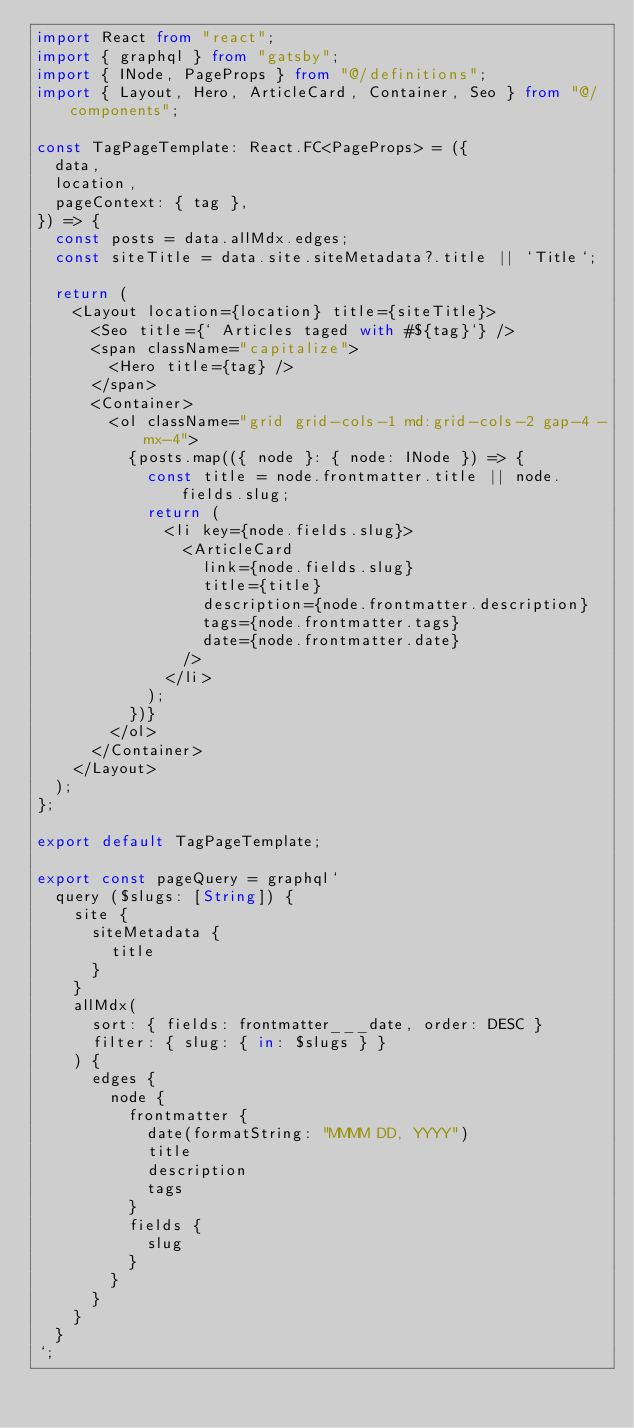Convert code to text. <code><loc_0><loc_0><loc_500><loc_500><_TypeScript_>import React from "react";
import { graphql } from "gatsby";
import { INode, PageProps } from "@/definitions";
import { Layout, Hero, ArticleCard, Container, Seo } from "@/components";

const TagPageTemplate: React.FC<PageProps> = ({
  data,
  location,
  pageContext: { tag },
}) => {
  const posts = data.allMdx.edges;
  const siteTitle = data.site.siteMetadata?.title || `Title`;

  return (
    <Layout location={location} title={siteTitle}>
      <Seo title={` Articles taged with #${tag}`} />
      <span className="capitalize">
        <Hero title={tag} />
      </span>
      <Container>
        <ol className="grid grid-cols-1 md:grid-cols-2 gap-4 -mx-4">
          {posts.map(({ node }: { node: INode }) => {
            const title = node.frontmatter.title || node.fields.slug;
            return (
              <li key={node.fields.slug}>
                <ArticleCard
                  link={node.fields.slug}
                  title={title}
                  description={node.frontmatter.description}
                  tags={node.frontmatter.tags}
                  date={node.frontmatter.date}
                />
              </li>
            );
          })}
        </ol>
      </Container>
    </Layout>
  );
};

export default TagPageTemplate;

export const pageQuery = graphql`
  query ($slugs: [String]) {
    site {
      siteMetadata {
        title
      }
    }
    allMdx(
      sort: { fields: frontmatter___date, order: DESC }
      filter: { slug: { in: $slugs } }
    ) {
      edges {
        node {
          frontmatter {
            date(formatString: "MMMM DD, YYYY")
            title
            description
            tags
          }
          fields {
            slug
          }
        }
      }
    }
  }
`;
</code> 